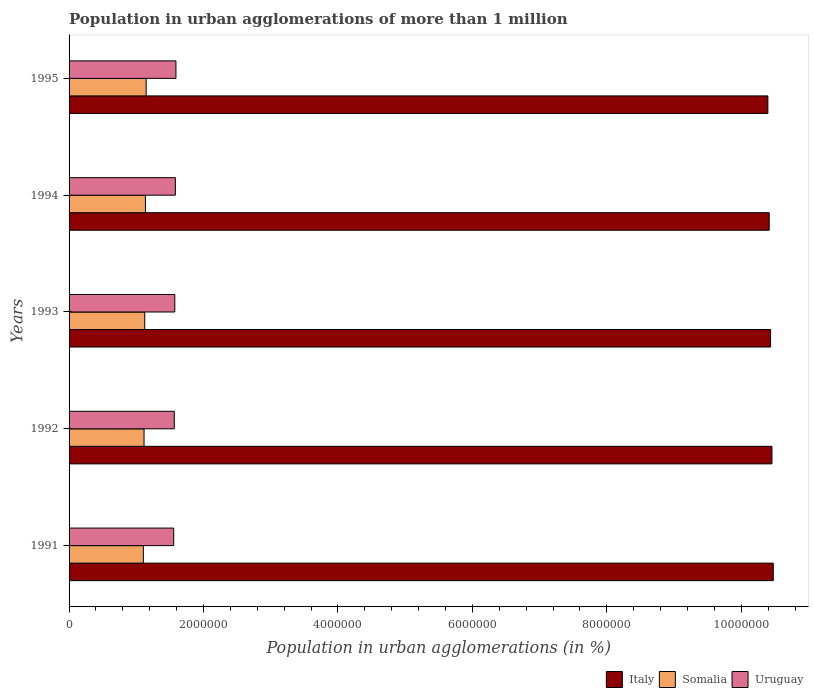How many different coloured bars are there?
Give a very brief answer. 3. How many groups of bars are there?
Give a very brief answer. 5. In how many cases, is the number of bars for a given year not equal to the number of legend labels?
Offer a terse response. 0. What is the population in urban agglomerations in Italy in 1992?
Your response must be concise. 1.05e+07. Across all years, what is the maximum population in urban agglomerations in Uruguay?
Your answer should be compact. 1.59e+06. Across all years, what is the minimum population in urban agglomerations in Italy?
Your answer should be very brief. 1.04e+07. In which year was the population in urban agglomerations in Uruguay maximum?
Ensure brevity in your answer.  1995. In which year was the population in urban agglomerations in Uruguay minimum?
Offer a very short reply. 1991. What is the total population in urban agglomerations in Italy in the graph?
Your answer should be very brief. 5.22e+07. What is the difference between the population in urban agglomerations in Somalia in 1991 and that in 1995?
Make the answer very short. -4.16e+04. What is the difference between the population in urban agglomerations in Italy in 1993 and the population in urban agglomerations in Uruguay in 1995?
Your answer should be very brief. 8.85e+06. What is the average population in urban agglomerations in Italy per year?
Give a very brief answer. 1.04e+07. In the year 1991, what is the difference between the population in urban agglomerations in Somalia and population in urban agglomerations in Uruguay?
Offer a terse response. -4.52e+05. What is the ratio of the population in urban agglomerations in Somalia in 1992 to that in 1994?
Provide a succinct answer. 0.98. Is the difference between the population in urban agglomerations in Somalia in 1992 and 1995 greater than the difference between the population in urban agglomerations in Uruguay in 1992 and 1995?
Ensure brevity in your answer.  No. What is the difference between the highest and the second highest population in urban agglomerations in Somalia?
Keep it short and to the point. 1.05e+04. What is the difference between the highest and the lowest population in urban agglomerations in Somalia?
Offer a terse response. 4.16e+04. What does the 1st bar from the top in 1994 represents?
Keep it short and to the point. Uruguay. Is it the case that in every year, the sum of the population in urban agglomerations in Italy and population in urban agglomerations in Somalia is greater than the population in urban agglomerations in Uruguay?
Make the answer very short. Yes. Are all the bars in the graph horizontal?
Provide a short and direct response. Yes. Are the values on the major ticks of X-axis written in scientific E-notation?
Offer a very short reply. No. Does the graph contain any zero values?
Offer a very short reply. No. Where does the legend appear in the graph?
Make the answer very short. Bottom right. How many legend labels are there?
Provide a short and direct response. 3. How are the legend labels stacked?
Offer a terse response. Horizontal. What is the title of the graph?
Make the answer very short. Population in urban agglomerations of more than 1 million. What is the label or title of the X-axis?
Give a very brief answer. Population in urban agglomerations (in %). What is the label or title of the Y-axis?
Provide a short and direct response. Years. What is the Population in urban agglomerations (in %) in Italy in 1991?
Offer a very short reply. 1.05e+07. What is the Population in urban agglomerations (in %) in Somalia in 1991?
Ensure brevity in your answer.  1.10e+06. What is the Population in urban agglomerations (in %) of Uruguay in 1991?
Offer a terse response. 1.56e+06. What is the Population in urban agglomerations (in %) of Italy in 1992?
Provide a succinct answer. 1.05e+07. What is the Population in urban agglomerations (in %) of Somalia in 1992?
Offer a terse response. 1.12e+06. What is the Population in urban agglomerations (in %) of Uruguay in 1992?
Your answer should be compact. 1.56e+06. What is the Population in urban agglomerations (in %) of Italy in 1993?
Offer a very short reply. 1.04e+07. What is the Population in urban agglomerations (in %) in Somalia in 1993?
Your answer should be very brief. 1.13e+06. What is the Population in urban agglomerations (in %) in Uruguay in 1993?
Offer a terse response. 1.57e+06. What is the Population in urban agglomerations (in %) of Italy in 1994?
Keep it short and to the point. 1.04e+07. What is the Population in urban agglomerations (in %) in Somalia in 1994?
Your answer should be very brief. 1.14e+06. What is the Population in urban agglomerations (in %) in Uruguay in 1994?
Provide a succinct answer. 1.58e+06. What is the Population in urban agglomerations (in %) of Italy in 1995?
Provide a succinct answer. 1.04e+07. What is the Population in urban agglomerations (in %) of Somalia in 1995?
Ensure brevity in your answer.  1.15e+06. What is the Population in urban agglomerations (in %) of Uruguay in 1995?
Keep it short and to the point. 1.59e+06. Across all years, what is the maximum Population in urban agglomerations (in %) of Italy?
Provide a short and direct response. 1.05e+07. Across all years, what is the maximum Population in urban agglomerations (in %) in Somalia?
Provide a short and direct response. 1.15e+06. Across all years, what is the maximum Population in urban agglomerations (in %) of Uruguay?
Your answer should be compact. 1.59e+06. Across all years, what is the minimum Population in urban agglomerations (in %) in Italy?
Your response must be concise. 1.04e+07. Across all years, what is the minimum Population in urban agglomerations (in %) of Somalia?
Offer a terse response. 1.10e+06. Across all years, what is the minimum Population in urban agglomerations (in %) of Uruguay?
Make the answer very short. 1.56e+06. What is the total Population in urban agglomerations (in %) of Italy in the graph?
Offer a very short reply. 5.22e+07. What is the total Population in urban agglomerations (in %) in Somalia in the graph?
Give a very brief answer. 5.63e+06. What is the total Population in urban agglomerations (in %) in Uruguay in the graph?
Provide a succinct answer. 7.87e+06. What is the difference between the Population in urban agglomerations (in %) in Italy in 1991 and that in 1992?
Keep it short and to the point. 2.00e+04. What is the difference between the Population in urban agglomerations (in %) in Somalia in 1991 and that in 1992?
Your answer should be compact. -1.03e+04. What is the difference between the Population in urban agglomerations (in %) in Uruguay in 1991 and that in 1992?
Offer a very short reply. -8192. What is the difference between the Population in urban agglomerations (in %) of Italy in 1991 and that in 1993?
Offer a very short reply. 4.02e+04. What is the difference between the Population in urban agglomerations (in %) of Somalia in 1991 and that in 1993?
Provide a short and direct response. -2.06e+04. What is the difference between the Population in urban agglomerations (in %) in Uruguay in 1991 and that in 1993?
Keep it short and to the point. -1.64e+04. What is the difference between the Population in urban agglomerations (in %) of Italy in 1991 and that in 1994?
Your response must be concise. 6.04e+04. What is the difference between the Population in urban agglomerations (in %) of Somalia in 1991 and that in 1994?
Offer a very short reply. -3.11e+04. What is the difference between the Population in urban agglomerations (in %) of Uruguay in 1991 and that in 1994?
Provide a short and direct response. -2.47e+04. What is the difference between the Population in urban agglomerations (in %) in Italy in 1991 and that in 1995?
Ensure brevity in your answer.  8.05e+04. What is the difference between the Population in urban agglomerations (in %) in Somalia in 1991 and that in 1995?
Offer a very short reply. -4.16e+04. What is the difference between the Population in urban agglomerations (in %) in Uruguay in 1991 and that in 1995?
Provide a short and direct response. -3.30e+04. What is the difference between the Population in urban agglomerations (in %) in Italy in 1992 and that in 1993?
Offer a terse response. 2.02e+04. What is the difference between the Population in urban agglomerations (in %) in Somalia in 1992 and that in 1993?
Your response must be concise. -1.03e+04. What is the difference between the Population in urban agglomerations (in %) in Uruguay in 1992 and that in 1993?
Your answer should be compact. -8213. What is the difference between the Population in urban agglomerations (in %) in Italy in 1992 and that in 1994?
Offer a terse response. 4.03e+04. What is the difference between the Population in urban agglomerations (in %) of Somalia in 1992 and that in 1994?
Make the answer very short. -2.08e+04. What is the difference between the Population in urban agglomerations (in %) in Uruguay in 1992 and that in 1994?
Offer a very short reply. -1.65e+04. What is the difference between the Population in urban agglomerations (in %) in Italy in 1992 and that in 1995?
Ensure brevity in your answer.  6.04e+04. What is the difference between the Population in urban agglomerations (in %) in Somalia in 1992 and that in 1995?
Provide a short and direct response. -3.13e+04. What is the difference between the Population in urban agglomerations (in %) of Uruguay in 1992 and that in 1995?
Offer a terse response. -2.48e+04. What is the difference between the Population in urban agglomerations (in %) of Italy in 1993 and that in 1994?
Your response must be concise. 2.01e+04. What is the difference between the Population in urban agglomerations (in %) in Somalia in 1993 and that in 1994?
Offer a terse response. -1.05e+04. What is the difference between the Population in urban agglomerations (in %) of Uruguay in 1993 and that in 1994?
Give a very brief answer. -8267. What is the difference between the Population in urban agglomerations (in %) in Italy in 1993 and that in 1995?
Your answer should be compact. 4.02e+04. What is the difference between the Population in urban agglomerations (in %) of Somalia in 1993 and that in 1995?
Provide a succinct answer. -2.10e+04. What is the difference between the Population in urban agglomerations (in %) of Uruguay in 1993 and that in 1995?
Provide a succinct answer. -1.66e+04. What is the difference between the Population in urban agglomerations (in %) of Italy in 1994 and that in 1995?
Offer a terse response. 2.01e+04. What is the difference between the Population in urban agglomerations (in %) of Somalia in 1994 and that in 1995?
Make the answer very short. -1.05e+04. What is the difference between the Population in urban agglomerations (in %) in Uruguay in 1994 and that in 1995?
Your answer should be very brief. -8311. What is the difference between the Population in urban agglomerations (in %) of Italy in 1991 and the Population in urban agglomerations (in %) of Somalia in 1992?
Give a very brief answer. 9.36e+06. What is the difference between the Population in urban agglomerations (in %) in Italy in 1991 and the Population in urban agglomerations (in %) in Uruguay in 1992?
Offer a very short reply. 8.91e+06. What is the difference between the Population in urban agglomerations (in %) in Somalia in 1991 and the Population in urban agglomerations (in %) in Uruguay in 1992?
Ensure brevity in your answer.  -4.60e+05. What is the difference between the Population in urban agglomerations (in %) in Italy in 1991 and the Population in urban agglomerations (in %) in Somalia in 1993?
Make the answer very short. 9.35e+06. What is the difference between the Population in urban agglomerations (in %) of Italy in 1991 and the Population in urban agglomerations (in %) of Uruguay in 1993?
Provide a succinct answer. 8.90e+06. What is the difference between the Population in urban agglomerations (in %) of Somalia in 1991 and the Population in urban agglomerations (in %) of Uruguay in 1993?
Provide a succinct answer. -4.68e+05. What is the difference between the Population in urban agglomerations (in %) in Italy in 1991 and the Population in urban agglomerations (in %) in Somalia in 1994?
Ensure brevity in your answer.  9.34e+06. What is the difference between the Population in urban agglomerations (in %) of Italy in 1991 and the Population in urban agglomerations (in %) of Uruguay in 1994?
Provide a short and direct response. 8.89e+06. What is the difference between the Population in urban agglomerations (in %) in Somalia in 1991 and the Population in urban agglomerations (in %) in Uruguay in 1994?
Your answer should be compact. -4.76e+05. What is the difference between the Population in urban agglomerations (in %) in Italy in 1991 and the Population in urban agglomerations (in %) in Somalia in 1995?
Offer a very short reply. 9.33e+06. What is the difference between the Population in urban agglomerations (in %) of Italy in 1991 and the Population in urban agglomerations (in %) of Uruguay in 1995?
Make the answer very short. 8.89e+06. What is the difference between the Population in urban agglomerations (in %) in Somalia in 1991 and the Population in urban agglomerations (in %) in Uruguay in 1995?
Provide a short and direct response. -4.85e+05. What is the difference between the Population in urban agglomerations (in %) of Italy in 1992 and the Population in urban agglomerations (in %) of Somalia in 1993?
Offer a terse response. 9.33e+06. What is the difference between the Population in urban agglomerations (in %) of Italy in 1992 and the Population in urban agglomerations (in %) of Uruguay in 1993?
Make the answer very short. 8.88e+06. What is the difference between the Population in urban agglomerations (in %) in Somalia in 1992 and the Population in urban agglomerations (in %) in Uruguay in 1993?
Provide a short and direct response. -4.58e+05. What is the difference between the Population in urban agglomerations (in %) in Italy in 1992 and the Population in urban agglomerations (in %) in Somalia in 1994?
Your answer should be very brief. 9.32e+06. What is the difference between the Population in urban agglomerations (in %) in Italy in 1992 and the Population in urban agglomerations (in %) in Uruguay in 1994?
Your answer should be very brief. 8.87e+06. What is the difference between the Population in urban agglomerations (in %) of Somalia in 1992 and the Population in urban agglomerations (in %) of Uruguay in 1994?
Provide a succinct answer. -4.66e+05. What is the difference between the Population in urban agglomerations (in %) in Italy in 1992 and the Population in urban agglomerations (in %) in Somalia in 1995?
Keep it short and to the point. 9.31e+06. What is the difference between the Population in urban agglomerations (in %) of Italy in 1992 and the Population in urban agglomerations (in %) of Uruguay in 1995?
Give a very brief answer. 8.87e+06. What is the difference between the Population in urban agglomerations (in %) of Somalia in 1992 and the Population in urban agglomerations (in %) of Uruguay in 1995?
Provide a short and direct response. -4.74e+05. What is the difference between the Population in urban agglomerations (in %) in Italy in 1993 and the Population in urban agglomerations (in %) in Somalia in 1994?
Offer a very short reply. 9.30e+06. What is the difference between the Population in urban agglomerations (in %) of Italy in 1993 and the Population in urban agglomerations (in %) of Uruguay in 1994?
Your response must be concise. 8.85e+06. What is the difference between the Population in urban agglomerations (in %) in Somalia in 1993 and the Population in urban agglomerations (in %) in Uruguay in 1994?
Offer a terse response. -4.56e+05. What is the difference between the Population in urban agglomerations (in %) of Italy in 1993 and the Population in urban agglomerations (in %) of Somalia in 1995?
Your response must be concise. 9.29e+06. What is the difference between the Population in urban agglomerations (in %) in Italy in 1993 and the Population in urban agglomerations (in %) in Uruguay in 1995?
Your answer should be very brief. 8.85e+06. What is the difference between the Population in urban agglomerations (in %) of Somalia in 1993 and the Population in urban agglomerations (in %) of Uruguay in 1995?
Give a very brief answer. -4.64e+05. What is the difference between the Population in urban agglomerations (in %) of Italy in 1994 and the Population in urban agglomerations (in %) of Somalia in 1995?
Your response must be concise. 9.27e+06. What is the difference between the Population in urban agglomerations (in %) in Italy in 1994 and the Population in urban agglomerations (in %) in Uruguay in 1995?
Ensure brevity in your answer.  8.83e+06. What is the difference between the Population in urban agglomerations (in %) of Somalia in 1994 and the Population in urban agglomerations (in %) of Uruguay in 1995?
Provide a short and direct response. -4.54e+05. What is the average Population in urban agglomerations (in %) in Italy per year?
Your answer should be compact. 1.04e+07. What is the average Population in urban agglomerations (in %) in Somalia per year?
Provide a succinct answer. 1.13e+06. What is the average Population in urban agglomerations (in %) of Uruguay per year?
Keep it short and to the point. 1.57e+06. In the year 1991, what is the difference between the Population in urban agglomerations (in %) of Italy and Population in urban agglomerations (in %) of Somalia?
Offer a very short reply. 9.37e+06. In the year 1991, what is the difference between the Population in urban agglomerations (in %) of Italy and Population in urban agglomerations (in %) of Uruguay?
Your answer should be very brief. 8.92e+06. In the year 1991, what is the difference between the Population in urban agglomerations (in %) of Somalia and Population in urban agglomerations (in %) of Uruguay?
Ensure brevity in your answer.  -4.52e+05. In the year 1992, what is the difference between the Population in urban agglomerations (in %) of Italy and Population in urban agglomerations (in %) of Somalia?
Provide a short and direct response. 9.34e+06. In the year 1992, what is the difference between the Population in urban agglomerations (in %) of Italy and Population in urban agglomerations (in %) of Uruguay?
Keep it short and to the point. 8.89e+06. In the year 1992, what is the difference between the Population in urban agglomerations (in %) of Somalia and Population in urban agglomerations (in %) of Uruguay?
Offer a very short reply. -4.50e+05. In the year 1993, what is the difference between the Population in urban agglomerations (in %) of Italy and Population in urban agglomerations (in %) of Somalia?
Offer a very short reply. 9.31e+06. In the year 1993, what is the difference between the Population in urban agglomerations (in %) of Italy and Population in urban agglomerations (in %) of Uruguay?
Offer a very short reply. 8.86e+06. In the year 1993, what is the difference between the Population in urban agglomerations (in %) of Somalia and Population in urban agglomerations (in %) of Uruguay?
Give a very brief answer. -4.47e+05. In the year 1994, what is the difference between the Population in urban agglomerations (in %) in Italy and Population in urban agglomerations (in %) in Somalia?
Provide a short and direct response. 9.28e+06. In the year 1994, what is the difference between the Population in urban agglomerations (in %) of Italy and Population in urban agglomerations (in %) of Uruguay?
Offer a very short reply. 8.83e+06. In the year 1994, what is the difference between the Population in urban agglomerations (in %) in Somalia and Population in urban agglomerations (in %) in Uruguay?
Offer a terse response. -4.45e+05. In the year 1995, what is the difference between the Population in urban agglomerations (in %) of Italy and Population in urban agglomerations (in %) of Somalia?
Keep it short and to the point. 9.25e+06. In the year 1995, what is the difference between the Population in urban agglomerations (in %) in Italy and Population in urban agglomerations (in %) in Uruguay?
Provide a short and direct response. 8.81e+06. In the year 1995, what is the difference between the Population in urban agglomerations (in %) of Somalia and Population in urban agglomerations (in %) of Uruguay?
Provide a succinct answer. -4.43e+05. What is the ratio of the Population in urban agglomerations (in %) in Italy in 1991 to that in 1993?
Make the answer very short. 1. What is the ratio of the Population in urban agglomerations (in %) of Somalia in 1991 to that in 1993?
Offer a very short reply. 0.98. What is the ratio of the Population in urban agglomerations (in %) of Uruguay in 1991 to that in 1993?
Your response must be concise. 0.99. What is the ratio of the Population in urban agglomerations (in %) of Somalia in 1991 to that in 1994?
Give a very brief answer. 0.97. What is the ratio of the Population in urban agglomerations (in %) of Uruguay in 1991 to that in 1994?
Make the answer very short. 0.98. What is the ratio of the Population in urban agglomerations (in %) of Italy in 1991 to that in 1995?
Offer a terse response. 1.01. What is the ratio of the Population in urban agglomerations (in %) in Somalia in 1991 to that in 1995?
Your answer should be very brief. 0.96. What is the ratio of the Population in urban agglomerations (in %) of Uruguay in 1991 to that in 1995?
Make the answer very short. 0.98. What is the ratio of the Population in urban agglomerations (in %) in Italy in 1992 to that in 1993?
Give a very brief answer. 1. What is the ratio of the Population in urban agglomerations (in %) in Somalia in 1992 to that in 1993?
Your answer should be compact. 0.99. What is the ratio of the Population in urban agglomerations (in %) of Somalia in 1992 to that in 1994?
Ensure brevity in your answer.  0.98. What is the ratio of the Population in urban agglomerations (in %) of Italy in 1992 to that in 1995?
Your response must be concise. 1.01. What is the ratio of the Population in urban agglomerations (in %) of Somalia in 1992 to that in 1995?
Offer a terse response. 0.97. What is the ratio of the Population in urban agglomerations (in %) in Uruguay in 1992 to that in 1995?
Make the answer very short. 0.98. What is the ratio of the Population in urban agglomerations (in %) in Italy in 1993 to that in 1994?
Your answer should be compact. 1. What is the ratio of the Population in urban agglomerations (in %) in Somalia in 1993 to that in 1995?
Offer a very short reply. 0.98. What is the ratio of the Population in urban agglomerations (in %) of Italy in 1994 to that in 1995?
Offer a terse response. 1. What is the ratio of the Population in urban agglomerations (in %) in Uruguay in 1994 to that in 1995?
Ensure brevity in your answer.  0.99. What is the difference between the highest and the second highest Population in urban agglomerations (in %) of Italy?
Your answer should be very brief. 2.00e+04. What is the difference between the highest and the second highest Population in urban agglomerations (in %) of Somalia?
Offer a very short reply. 1.05e+04. What is the difference between the highest and the second highest Population in urban agglomerations (in %) in Uruguay?
Your response must be concise. 8311. What is the difference between the highest and the lowest Population in urban agglomerations (in %) in Italy?
Your answer should be compact. 8.05e+04. What is the difference between the highest and the lowest Population in urban agglomerations (in %) of Somalia?
Your answer should be compact. 4.16e+04. What is the difference between the highest and the lowest Population in urban agglomerations (in %) in Uruguay?
Offer a terse response. 3.30e+04. 